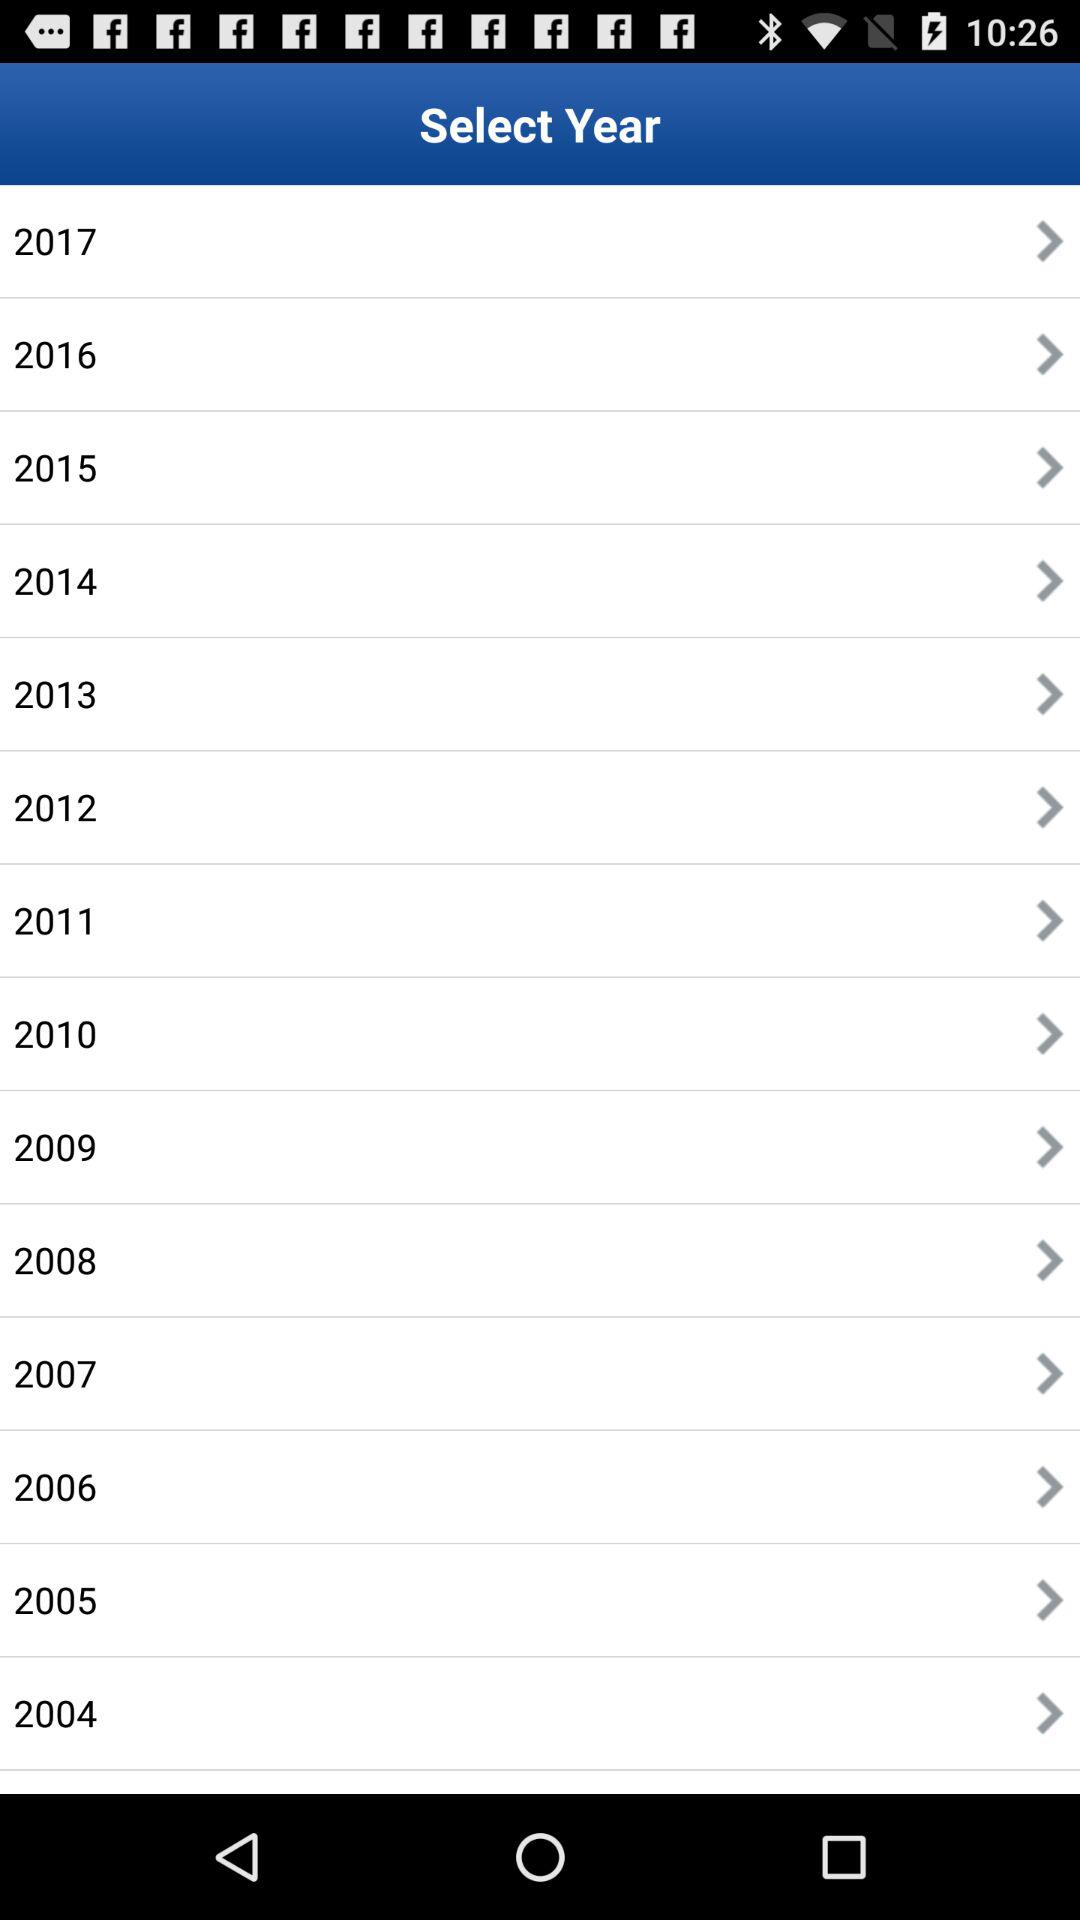How many years are available to select from?
Answer the question using a single word or phrase. 14 